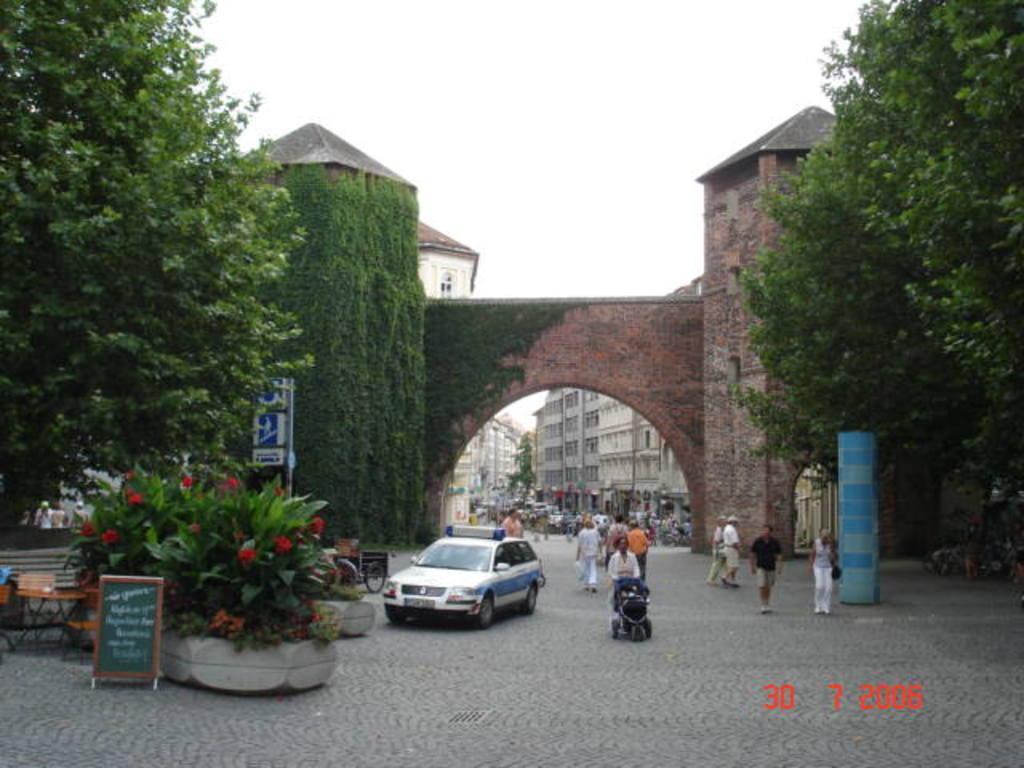In one or two sentences, can you explain what this image depicts? In this image I can see some people. I can see the vehicles. On the left and right side, I can see the trees. In the middle I can see the wall. In the background, I can see the buildings and the sky. 